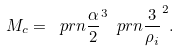<formula> <loc_0><loc_0><loc_500><loc_500>M _ { c } = \ p r n { \frac { \alpha } { 2 } } ^ { 3 } \ p r n { \frac { 3 } { \rho _ { i } } } ^ { 2 } .</formula> 